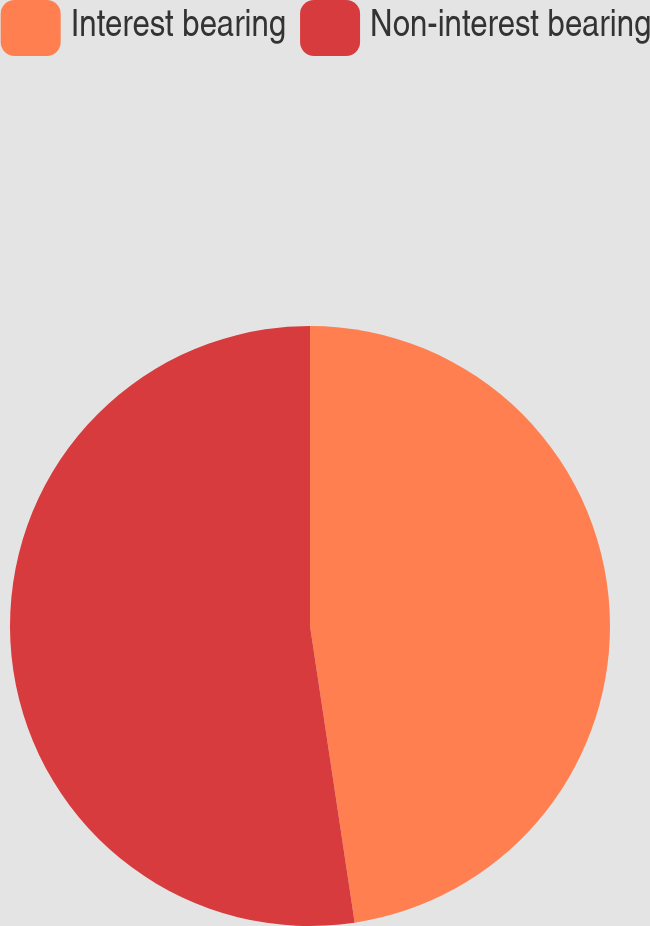Convert chart. <chart><loc_0><loc_0><loc_500><loc_500><pie_chart><fcel>Interest bearing<fcel>Non-interest bearing<nl><fcel>47.62%<fcel>52.38%<nl></chart> 